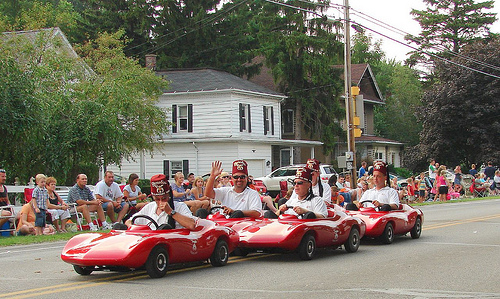<image>
Can you confirm if the girl is to the left of the man? Yes. From this viewpoint, the girl is positioned to the left side relative to the man. Is the man under the car? No. The man is not positioned under the car. The vertical relationship between these objects is different. Where is the man in relation to the house? Is it to the right of the house? No. The man is not to the right of the house. The horizontal positioning shows a different relationship. Is the building in front of the man? No. The building is not in front of the man. The spatial positioning shows a different relationship between these objects. 